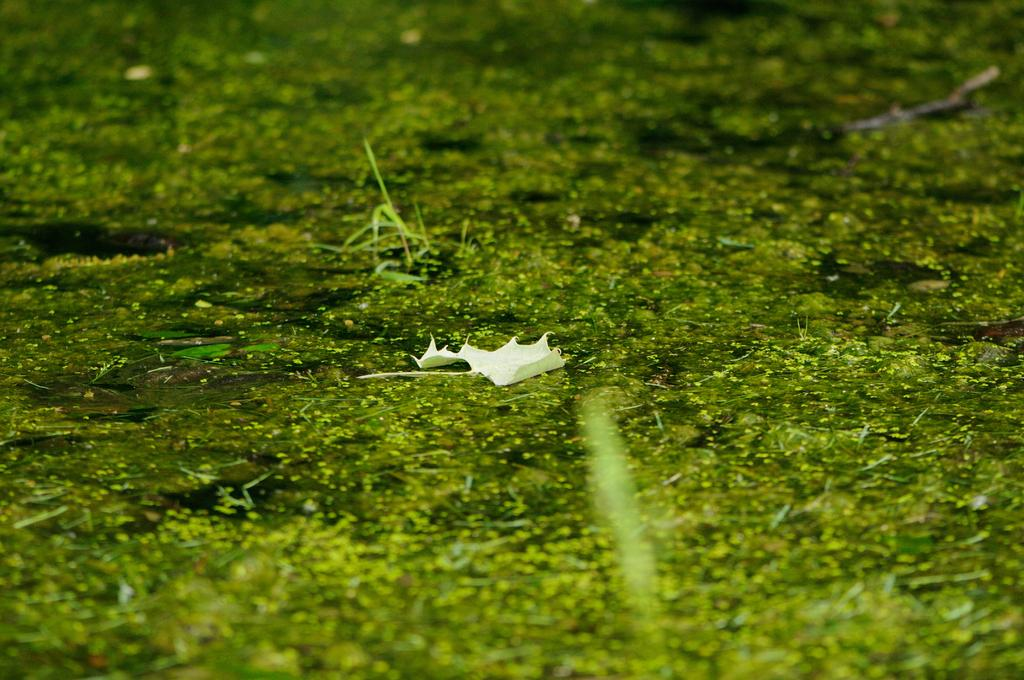What is present in the image that is related to plants? There is a leaf in the image. What color is the object in the image? There is an object in green color in the image. What type of support can be seen in the image? There is no support visible in the image. What is the rate of the object in the image? The rate of the object cannot be determined from the image, as it does not provide any information about speed or progress. 